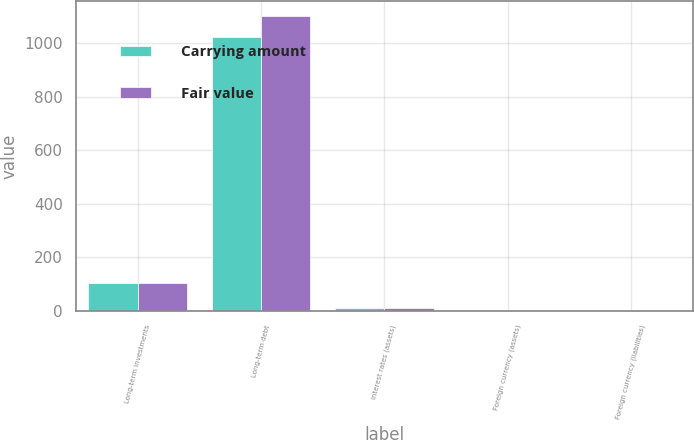Convert chart. <chart><loc_0><loc_0><loc_500><loc_500><stacked_bar_chart><ecel><fcel>Long-term investments<fcel>Long-term debt<fcel>Interest rates (assets)<fcel>Foreign currency (assets)<fcel>Foreign currency (liabilities)<nl><fcel>Carrying amount<fcel>103.4<fcel>1021.5<fcel>12.2<fcel>1.1<fcel>1.6<nl><fcel>Fair value<fcel>103.4<fcel>1102.4<fcel>12.2<fcel>1.1<fcel>1.6<nl></chart> 